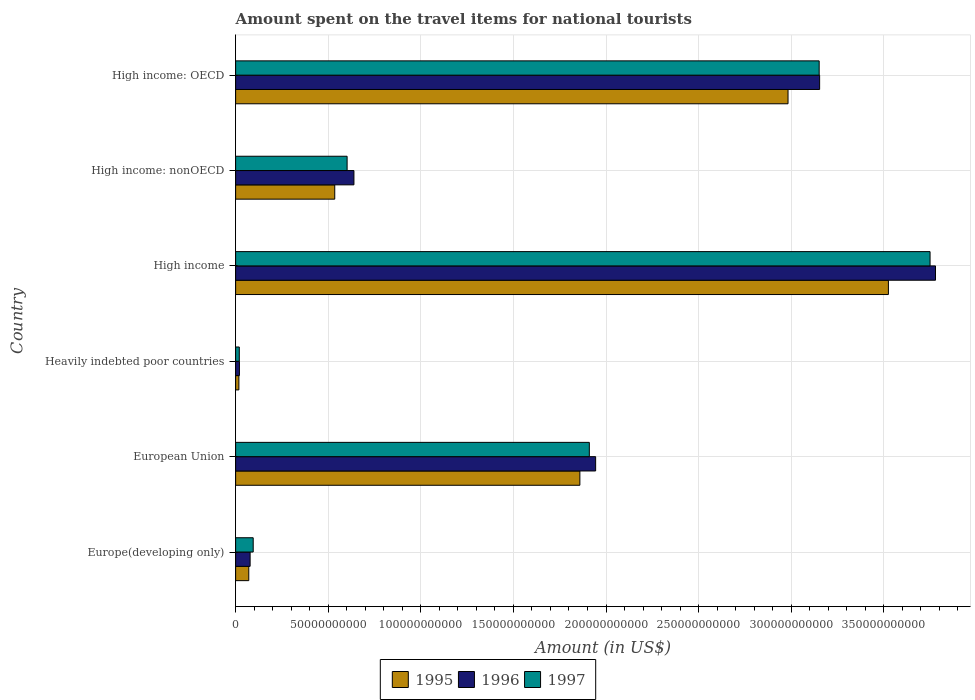How many groups of bars are there?
Offer a terse response. 6. Are the number of bars per tick equal to the number of legend labels?
Your answer should be very brief. Yes. What is the label of the 3rd group of bars from the top?
Your response must be concise. High income. What is the amount spent on the travel items for national tourists in 1995 in High income: nonOECD?
Keep it short and to the point. 5.35e+1. Across all countries, what is the maximum amount spent on the travel items for national tourists in 1997?
Offer a terse response. 3.75e+11. Across all countries, what is the minimum amount spent on the travel items for national tourists in 1995?
Give a very brief answer. 1.77e+09. In which country was the amount spent on the travel items for national tourists in 1996 maximum?
Your answer should be very brief. High income. In which country was the amount spent on the travel items for national tourists in 1995 minimum?
Your answer should be compact. Heavily indebted poor countries. What is the total amount spent on the travel items for national tourists in 1996 in the graph?
Your response must be concise. 9.61e+11. What is the difference between the amount spent on the travel items for national tourists in 1995 in High income and that in High income: OECD?
Provide a succinct answer. 5.42e+1. What is the difference between the amount spent on the travel items for national tourists in 1996 in High income: OECD and the amount spent on the travel items for national tourists in 1997 in High income: nonOECD?
Your answer should be very brief. 2.55e+11. What is the average amount spent on the travel items for national tourists in 1995 per country?
Your answer should be very brief. 1.50e+11. What is the difference between the amount spent on the travel items for national tourists in 1995 and amount spent on the travel items for national tourists in 1997 in High income: nonOECD?
Ensure brevity in your answer.  -6.67e+09. What is the ratio of the amount spent on the travel items for national tourists in 1997 in Heavily indebted poor countries to that in High income: nonOECD?
Make the answer very short. 0.03. What is the difference between the highest and the second highest amount spent on the travel items for national tourists in 1996?
Your answer should be compact. 6.26e+1. What is the difference between the highest and the lowest amount spent on the travel items for national tourists in 1996?
Ensure brevity in your answer.  3.76e+11. What does the 3rd bar from the bottom in High income: OECD represents?
Offer a terse response. 1997. Are all the bars in the graph horizontal?
Ensure brevity in your answer.  Yes. How many countries are there in the graph?
Provide a short and direct response. 6. Are the values on the major ticks of X-axis written in scientific E-notation?
Your answer should be compact. No. Does the graph contain any zero values?
Offer a terse response. No. Where does the legend appear in the graph?
Make the answer very short. Bottom center. How many legend labels are there?
Keep it short and to the point. 3. How are the legend labels stacked?
Offer a very short reply. Horizontal. What is the title of the graph?
Your response must be concise. Amount spent on the travel items for national tourists. Does "1997" appear as one of the legend labels in the graph?
Keep it short and to the point. Yes. What is the label or title of the Y-axis?
Offer a very short reply. Country. What is the Amount (in US$) in 1995 in Europe(developing only)?
Make the answer very short. 7.10e+09. What is the Amount (in US$) in 1996 in Europe(developing only)?
Provide a succinct answer. 7.83e+09. What is the Amount (in US$) of 1997 in Europe(developing only)?
Your answer should be very brief. 9.50e+09. What is the Amount (in US$) in 1995 in European Union?
Your answer should be compact. 1.86e+11. What is the Amount (in US$) of 1996 in European Union?
Make the answer very short. 1.94e+11. What is the Amount (in US$) of 1997 in European Union?
Provide a short and direct response. 1.91e+11. What is the Amount (in US$) of 1995 in Heavily indebted poor countries?
Your answer should be very brief. 1.77e+09. What is the Amount (in US$) of 1996 in Heavily indebted poor countries?
Your answer should be very brief. 2.06e+09. What is the Amount (in US$) in 1997 in Heavily indebted poor countries?
Your answer should be very brief. 1.99e+09. What is the Amount (in US$) of 1995 in High income?
Ensure brevity in your answer.  3.52e+11. What is the Amount (in US$) in 1996 in High income?
Provide a succinct answer. 3.78e+11. What is the Amount (in US$) of 1997 in High income?
Give a very brief answer. 3.75e+11. What is the Amount (in US$) in 1995 in High income: nonOECD?
Your response must be concise. 5.35e+1. What is the Amount (in US$) in 1996 in High income: nonOECD?
Your answer should be very brief. 6.39e+1. What is the Amount (in US$) of 1997 in High income: nonOECD?
Offer a very short reply. 6.02e+1. What is the Amount (in US$) in 1995 in High income: OECD?
Offer a very short reply. 2.98e+11. What is the Amount (in US$) in 1996 in High income: OECD?
Provide a succinct answer. 3.15e+11. What is the Amount (in US$) of 1997 in High income: OECD?
Offer a very short reply. 3.15e+11. Across all countries, what is the maximum Amount (in US$) in 1995?
Your answer should be very brief. 3.52e+11. Across all countries, what is the maximum Amount (in US$) of 1996?
Offer a terse response. 3.78e+11. Across all countries, what is the maximum Amount (in US$) in 1997?
Offer a very short reply. 3.75e+11. Across all countries, what is the minimum Amount (in US$) of 1995?
Offer a terse response. 1.77e+09. Across all countries, what is the minimum Amount (in US$) of 1996?
Offer a terse response. 2.06e+09. Across all countries, what is the minimum Amount (in US$) of 1997?
Offer a terse response. 1.99e+09. What is the total Amount (in US$) of 1995 in the graph?
Your response must be concise. 8.99e+11. What is the total Amount (in US$) in 1996 in the graph?
Provide a succinct answer. 9.61e+11. What is the total Amount (in US$) in 1997 in the graph?
Offer a terse response. 9.53e+11. What is the difference between the Amount (in US$) in 1995 in Europe(developing only) and that in European Union?
Provide a succinct answer. -1.79e+11. What is the difference between the Amount (in US$) of 1996 in Europe(developing only) and that in European Union?
Your response must be concise. -1.87e+11. What is the difference between the Amount (in US$) of 1997 in Europe(developing only) and that in European Union?
Ensure brevity in your answer.  -1.81e+11. What is the difference between the Amount (in US$) in 1995 in Europe(developing only) and that in Heavily indebted poor countries?
Offer a terse response. 5.34e+09. What is the difference between the Amount (in US$) in 1996 in Europe(developing only) and that in Heavily indebted poor countries?
Make the answer very short. 5.77e+09. What is the difference between the Amount (in US$) in 1997 in Europe(developing only) and that in Heavily indebted poor countries?
Keep it short and to the point. 7.51e+09. What is the difference between the Amount (in US$) in 1995 in Europe(developing only) and that in High income?
Offer a terse response. -3.45e+11. What is the difference between the Amount (in US$) of 1996 in Europe(developing only) and that in High income?
Provide a succinct answer. -3.70e+11. What is the difference between the Amount (in US$) in 1997 in Europe(developing only) and that in High income?
Provide a short and direct response. -3.65e+11. What is the difference between the Amount (in US$) in 1995 in Europe(developing only) and that in High income: nonOECD?
Provide a succinct answer. -4.64e+1. What is the difference between the Amount (in US$) of 1996 in Europe(developing only) and that in High income: nonOECD?
Your answer should be compact. -5.61e+1. What is the difference between the Amount (in US$) in 1997 in Europe(developing only) and that in High income: nonOECD?
Offer a very short reply. -5.07e+1. What is the difference between the Amount (in US$) in 1995 in Europe(developing only) and that in High income: OECD?
Your answer should be very brief. -2.91e+11. What is the difference between the Amount (in US$) in 1996 in Europe(developing only) and that in High income: OECD?
Your response must be concise. -3.08e+11. What is the difference between the Amount (in US$) of 1997 in Europe(developing only) and that in High income: OECD?
Provide a short and direct response. -3.06e+11. What is the difference between the Amount (in US$) in 1995 in European Union and that in Heavily indebted poor countries?
Your response must be concise. 1.84e+11. What is the difference between the Amount (in US$) of 1996 in European Union and that in Heavily indebted poor countries?
Make the answer very short. 1.92e+11. What is the difference between the Amount (in US$) of 1997 in European Union and that in Heavily indebted poor countries?
Keep it short and to the point. 1.89e+11. What is the difference between the Amount (in US$) of 1995 in European Union and that in High income?
Give a very brief answer. -1.67e+11. What is the difference between the Amount (in US$) in 1996 in European Union and that in High income?
Give a very brief answer. -1.84e+11. What is the difference between the Amount (in US$) of 1997 in European Union and that in High income?
Offer a very short reply. -1.84e+11. What is the difference between the Amount (in US$) of 1995 in European Union and that in High income: nonOECD?
Offer a terse response. 1.32e+11. What is the difference between the Amount (in US$) in 1996 in European Union and that in High income: nonOECD?
Provide a short and direct response. 1.31e+11. What is the difference between the Amount (in US$) in 1997 in European Union and that in High income: nonOECD?
Your response must be concise. 1.31e+11. What is the difference between the Amount (in US$) in 1995 in European Union and that in High income: OECD?
Make the answer very short. -1.12e+11. What is the difference between the Amount (in US$) of 1996 in European Union and that in High income: OECD?
Your answer should be compact. -1.21e+11. What is the difference between the Amount (in US$) in 1997 in European Union and that in High income: OECD?
Provide a succinct answer. -1.24e+11. What is the difference between the Amount (in US$) of 1995 in Heavily indebted poor countries and that in High income?
Give a very brief answer. -3.51e+11. What is the difference between the Amount (in US$) in 1996 in Heavily indebted poor countries and that in High income?
Provide a short and direct response. -3.76e+11. What is the difference between the Amount (in US$) of 1997 in Heavily indebted poor countries and that in High income?
Your response must be concise. -3.73e+11. What is the difference between the Amount (in US$) of 1995 in Heavily indebted poor countries and that in High income: nonOECD?
Your answer should be compact. -5.18e+1. What is the difference between the Amount (in US$) in 1996 in Heavily indebted poor countries and that in High income: nonOECD?
Offer a terse response. -6.18e+1. What is the difference between the Amount (in US$) of 1997 in Heavily indebted poor countries and that in High income: nonOECD?
Make the answer very short. -5.82e+1. What is the difference between the Amount (in US$) of 1995 in Heavily indebted poor countries and that in High income: OECD?
Keep it short and to the point. -2.97e+11. What is the difference between the Amount (in US$) in 1996 in Heavily indebted poor countries and that in High income: OECD?
Offer a terse response. -3.13e+11. What is the difference between the Amount (in US$) of 1997 in Heavily indebted poor countries and that in High income: OECD?
Make the answer very short. -3.13e+11. What is the difference between the Amount (in US$) of 1995 in High income and that in High income: nonOECD?
Give a very brief answer. 2.99e+11. What is the difference between the Amount (in US$) in 1996 in High income and that in High income: nonOECD?
Make the answer very short. 3.14e+11. What is the difference between the Amount (in US$) of 1997 in High income and that in High income: nonOECD?
Provide a succinct answer. 3.15e+11. What is the difference between the Amount (in US$) of 1995 in High income and that in High income: OECD?
Give a very brief answer. 5.42e+1. What is the difference between the Amount (in US$) in 1996 in High income and that in High income: OECD?
Your response must be concise. 6.26e+1. What is the difference between the Amount (in US$) in 1997 in High income and that in High income: OECD?
Your answer should be very brief. 5.99e+1. What is the difference between the Amount (in US$) in 1995 in High income: nonOECD and that in High income: OECD?
Make the answer very short. -2.45e+11. What is the difference between the Amount (in US$) in 1996 in High income: nonOECD and that in High income: OECD?
Make the answer very short. -2.51e+11. What is the difference between the Amount (in US$) in 1997 in High income: nonOECD and that in High income: OECD?
Ensure brevity in your answer.  -2.55e+11. What is the difference between the Amount (in US$) of 1995 in Europe(developing only) and the Amount (in US$) of 1996 in European Union?
Make the answer very short. -1.87e+11. What is the difference between the Amount (in US$) in 1995 in Europe(developing only) and the Amount (in US$) in 1997 in European Union?
Your response must be concise. -1.84e+11. What is the difference between the Amount (in US$) in 1996 in Europe(developing only) and the Amount (in US$) in 1997 in European Union?
Ensure brevity in your answer.  -1.83e+11. What is the difference between the Amount (in US$) in 1995 in Europe(developing only) and the Amount (in US$) in 1996 in Heavily indebted poor countries?
Your answer should be compact. 5.05e+09. What is the difference between the Amount (in US$) of 1995 in Europe(developing only) and the Amount (in US$) of 1997 in Heavily indebted poor countries?
Make the answer very short. 5.12e+09. What is the difference between the Amount (in US$) of 1996 in Europe(developing only) and the Amount (in US$) of 1997 in Heavily indebted poor countries?
Your response must be concise. 5.84e+09. What is the difference between the Amount (in US$) in 1995 in Europe(developing only) and the Amount (in US$) in 1996 in High income?
Your response must be concise. -3.71e+11. What is the difference between the Amount (in US$) of 1995 in Europe(developing only) and the Amount (in US$) of 1997 in High income?
Your response must be concise. -3.68e+11. What is the difference between the Amount (in US$) in 1996 in Europe(developing only) and the Amount (in US$) in 1997 in High income?
Make the answer very short. -3.67e+11. What is the difference between the Amount (in US$) in 1995 in Europe(developing only) and the Amount (in US$) in 1996 in High income: nonOECD?
Provide a succinct answer. -5.68e+1. What is the difference between the Amount (in US$) in 1995 in Europe(developing only) and the Amount (in US$) in 1997 in High income: nonOECD?
Give a very brief answer. -5.31e+1. What is the difference between the Amount (in US$) of 1996 in Europe(developing only) and the Amount (in US$) of 1997 in High income: nonOECD?
Provide a succinct answer. -5.24e+1. What is the difference between the Amount (in US$) of 1995 in Europe(developing only) and the Amount (in US$) of 1996 in High income: OECD?
Make the answer very short. -3.08e+11. What is the difference between the Amount (in US$) of 1995 in Europe(developing only) and the Amount (in US$) of 1997 in High income: OECD?
Provide a short and direct response. -3.08e+11. What is the difference between the Amount (in US$) of 1996 in Europe(developing only) and the Amount (in US$) of 1997 in High income: OECD?
Your response must be concise. -3.07e+11. What is the difference between the Amount (in US$) in 1995 in European Union and the Amount (in US$) in 1996 in Heavily indebted poor countries?
Give a very brief answer. 1.84e+11. What is the difference between the Amount (in US$) in 1995 in European Union and the Amount (in US$) in 1997 in Heavily indebted poor countries?
Make the answer very short. 1.84e+11. What is the difference between the Amount (in US$) of 1996 in European Union and the Amount (in US$) of 1997 in Heavily indebted poor countries?
Offer a terse response. 1.92e+11. What is the difference between the Amount (in US$) in 1995 in European Union and the Amount (in US$) in 1996 in High income?
Give a very brief answer. -1.92e+11. What is the difference between the Amount (in US$) of 1995 in European Union and the Amount (in US$) of 1997 in High income?
Offer a very short reply. -1.89e+11. What is the difference between the Amount (in US$) of 1996 in European Union and the Amount (in US$) of 1997 in High income?
Your response must be concise. -1.81e+11. What is the difference between the Amount (in US$) of 1995 in European Union and the Amount (in US$) of 1996 in High income: nonOECD?
Provide a short and direct response. 1.22e+11. What is the difference between the Amount (in US$) of 1995 in European Union and the Amount (in US$) of 1997 in High income: nonOECD?
Offer a terse response. 1.26e+11. What is the difference between the Amount (in US$) in 1996 in European Union and the Amount (in US$) in 1997 in High income: nonOECD?
Give a very brief answer. 1.34e+11. What is the difference between the Amount (in US$) of 1995 in European Union and the Amount (in US$) of 1996 in High income: OECD?
Keep it short and to the point. -1.29e+11. What is the difference between the Amount (in US$) in 1995 in European Union and the Amount (in US$) in 1997 in High income: OECD?
Your answer should be compact. -1.29e+11. What is the difference between the Amount (in US$) in 1996 in European Union and the Amount (in US$) in 1997 in High income: OECD?
Your answer should be very brief. -1.21e+11. What is the difference between the Amount (in US$) of 1995 in Heavily indebted poor countries and the Amount (in US$) of 1996 in High income?
Your answer should be compact. -3.76e+11. What is the difference between the Amount (in US$) in 1995 in Heavily indebted poor countries and the Amount (in US$) in 1997 in High income?
Make the answer very short. -3.73e+11. What is the difference between the Amount (in US$) in 1996 in Heavily indebted poor countries and the Amount (in US$) in 1997 in High income?
Make the answer very short. -3.73e+11. What is the difference between the Amount (in US$) of 1995 in Heavily indebted poor countries and the Amount (in US$) of 1996 in High income: nonOECD?
Make the answer very short. -6.21e+1. What is the difference between the Amount (in US$) of 1995 in Heavily indebted poor countries and the Amount (in US$) of 1997 in High income: nonOECD?
Make the answer very short. -5.84e+1. What is the difference between the Amount (in US$) of 1996 in Heavily indebted poor countries and the Amount (in US$) of 1997 in High income: nonOECD?
Provide a succinct answer. -5.81e+1. What is the difference between the Amount (in US$) of 1995 in Heavily indebted poor countries and the Amount (in US$) of 1996 in High income: OECD?
Your answer should be compact. -3.14e+11. What is the difference between the Amount (in US$) of 1995 in Heavily indebted poor countries and the Amount (in US$) of 1997 in High income: OECD?
Your answer should be very brief. -3.13e+11. What is the difference between the Amount (in US$) in 1996 in Heavily indebted poor countries and the Amount (in US$) in 1997 in High income: OECD?
Ensure brevity in your answer.  -3.13e+11. What is the difference between the Amount (in US$) in 1995 in High income and the Amount (in US$) in 1996 in High income: nonOECD?
Offer a terse response. 2.89e+11. What is the difference between the Amount (in US$) in 1995 in High income and the Amount (in US$) in 1997 in High income: nonOECD?
Your answer should be compact. 2.92e+11. What is the difference between the Amount (in US$) in 1996 in High income and the Amount (in US$) in 1997 in High income: nonOECD?
Keep it short and to the point. 3.18e+11. What is the difference between the Amount (in US$) of 1995 in High income and the Amount (in US$) of 1996 in High income: OECD?
Make the answer very short. 3.71e+1. What is the difference between the Amount (in US$) in 1995 in High income and the Amount (in US$) in 1997 in High income: OECD?
Make the answer very short. 3.74e+1. What is the difference between the Amount (in US$) of 1996 in High income and the Amount (in US$) of 1997 in High income: OECD?
Give a very brief answer. 6.28e+1. What is the difference between the Amount (in US$) of 1995 in High income: nonOECD and the Amount (in US$) of 1996 in High income: OECD?
Offer a very short reply. -2.62e+11. What is the difference between the Amount (in US$) in 1995 in High income: nonOECD and the Amount (in US$) in 1997 in High income: OECD?
Make the answer very short. -2.62e+11. What is the difference between the Amount (in US$) in 1996 in High income: nonOECD and the Amount (in US$) in 1997 in High income: OECD?
Your answer should be very brief. -2.51e+11. What is the average Amount (in US$) of 1995 per country?
Keep it short and to the point. 1.50e+11. What is the average Amount (in US$) of 1996 per country?
Offer a very short reply. 1.60e+11. What is the average Amount (in US$) in 1997 per country?
Provide a succinct answer. 1.59e+11. What is the difference between the Amount (in US$) in 1995 and Amount (in US$) in 1996 in Europe(developing only)?
Make the answer very short. -7.25e+08. What is the difference between the Amount (in US$) of 1995 and Amount (in US$) of 1997 in Europe(developing only)?
Your answer should be compact. -2.39e+09. What is the difference between the Amount (in US$) in 1996 and Amount (in US$) in 1997 in Europe(developing only)?
Your response must be concise. -1.67e+09. What is the difference between the Amount (in US$) of 1995 and Amount (in US$) of 1996 in European Union?
Ensure brevity in your answer.  -8.51e+09. What is the difference between the Amount (in US$) in 1995 and Amount (in US$) in 1997 in European Union?
Provide a succinct answer. -5.10e+09. What is the difference between the Amount (in US$) in 1996 and Amount (in US$) in 1997 in European Union?
Ensure brevity in your answer.  3.41e+09. What is the difference between the Amount (in US$) in 1995 and Amount (in US$) in 1996 in Heavily indebted poor countries?
Your answer should be very brief. -2.89e+08. What is the difference between the Amount (in US$) of 1995 and Amount (in US$) of 1997 in Heavily indebted poor countries?
Make the answer very short. -2.21e+08. What is the difference between the Amount (in US$) of 1996 and Amount (in US$) of 1997 in Heavily indebted poor countries?
Keep it short and to the point. 6.82e+07. What is the difference between the Amount (in US$) of 1995 and Amount (in US$) of 1996 in High income?
Offer a terse response. -2.54e+1. What is the difference between the Amount (in US$) of 1995 and Amount (in US$) of 1997 in High income?
Make the answer very short. -2.25e+1. What is the difference between the Amount (in US$) of 1996 and Amount (in US$) of 1997 in High income?
Your answer should be very brief. 2.94e+09. What is the difference between the Amount (in US$) in 1995 and Amount (in US$) in 1996 in High income: nonOECD?
Your answer should be very brief. -1.04e+1. What is the difference between the Amount (in US$) of 1995 and Amount (in US$) of 1997 in High income: nonOECD?
Offer a very short reply. -6.67e+09. What is the difference between the Amount (in US$) in 1996 and Amount (in US$) in 1997 in High income: nonOECD?
Make the answer very short. 3.69e+09. What is the difference between the Amount (in US$) in 1995 and Amount (in US$) in 1996 in High income: OECD?
Provide a succinct answer. -1.71e+1. What is the difference between the Amount (in US$) in 1995 and Amount (in US$) in 1997 in High income: OECD?
Provide a short and direct response. -1.68e+1. What is the difference between the Amount (in US$) of 1996 and Amount (in US$) of 1997 in High income: OECD?
Offer a terse response. 2.50e+08. What is the ratio of the Amount (in US$) in 1995 in Europe(developing only) to that in European Union?
Your answer should be very brief. 0.04. What is the ratio of the Amount (in US$) in 1996 in Europe(developing only) to that in European Union?
Keep it short and to the point. 0.04. What is the ratio of the Amount (in US$) of 1997 in Europe(developing only) to that in European Union?
Provide a succinct answer. 0.05. What is the ratio of the Amount (in US$) of 1995 in Europe(developing only) to that in Heavily indebted poor countries?
Offer a very short reply. 4.02. What is the ratio of the Amount (in US$) in 1996 in Europe(developing only) to that in Heavily indebted poor countries?
Offer a very short reply. 3.81. What is the ratio of the Amount (in US$) in 1997 in Europe(developing only) to that in Heavily indebted poor countries?
Ensure brevity in your answer.  4.78. What is the ratio of the Amount (in US$) of 1995 in Europe(developing only) to that in High income?
Keep it short and to the point. 0.02. What is the ratio of the Amount (in US$) of 1996 in Europe(developing only) to that in High income?
Provide a short and direct response. 0.02. What is the ratio of the Amount (in US$) in 1997 in Europe(developing only) to that in High income?
Your answer should be compact. 0.03. What is the ratio of the Amount (in US$) in 1995 in Europe(developing only) to that in High income: nonOECD?
Your response must be concise. 0.13. What is the ratio of the Amount (in US$) in 1996 in Europe(developing only) to that in High income: nonOECD?
Provide a succinct answer. 0.12. What is the ratio of the Amount (in US$) of 1997 in Europe(developing only) to that in High income: nonOECD?
Give a very brief answer. 0.16. What is the ratio of the Amount (in US$) of 1995 in Europe(developing only) to that in High income: OECD?
Ensure brevity in your answer.  0.02. What is the ratio of the Amount (in US$) in 1996 in Europe(developing only) to that in High income: OECD?
Your answer should be very brief. 0.02. What is the ratio of the Amount (in US$) of 1997 in Europe(developing only) to that in High income: OECD?
Offer a terse response. 0.03. What is the ratio of the Amount (in US$) of 1995 in European Union to that in Heavily indebted poor countries?
Make the answer very short. 105.17. What is the ratio of the Amount (in US$) of 1996 in European Union to that in Heavily indebted poor countries?
Your answer should be very brief. 94.53. What is the ratio of the Amount (in US$) of 1997 in European Union to that in Heavily indebted poor countries?
Make the answer very short. 96.05. What is the ratio of the Amount (in US$) of 1995 in European Union to that in High income?
Provide a succinct answer. 0.53. What is the ratio of the Amount (in US$) in 1996 in European Union to that in High income?
Make the answer very short. 0.51. What is the ratio of the Amount (in US$) in 1997 in European Union to that in High income?
Offer a terse response. 0.51. What is the ratio of the Amount (in US$) of 1995 in European Union to that in High income: nonOECD?
Ensure brevity in your answer.  3.47. What is the ratio of the Amount (in US$) in 1996 in European Union to that in High income: nonOECD?
Ensure brevity in your answer.  3.04. What is the ratio of the Amount (in US$) of 1997 in European Union to that in High income: nonOECD?
Offer a very short reply. 3.17. What is the ratio of the Amount (in US$) of 1995 in European Union to that in High income: OECD?
Your response must be concise. 0.62. What is the ratio of the Amount (in US$) of 1996 in European Union to that in High income: OECD?
Keep it short and to the point. 0.62. What is the ratio of the Amount (in US$) in 1997 in European Union to that in High income: OECD?
Your answer should be very brief. 0.61. What is the ratio of the Amount (in US$) in 1995 in Heavily indebted poor countries to that in High income?
Ensure brevity in your answer.  0.01. What is the ratio of the Amount (in US$) of 1996 in Heavily indebted poor countries to that in High income?
Provide a succinct answer. 0.01. What is the ratio of the Amount (in US$) of 1997 in Heavily indebted poor countries to that in High income?
Offer a terse response. 0.01. What is the ratio of the Amount (in US$) in 1995 in Heavily indebted poor countries to that in High income: nonOECD?
Provide a short and direct response. 0.03. What is the ratio of the Amount (in US$) in 1996 in Heavily indebted poor countries to that in High income: nonOECD?
Offer a terse response. 0.03. What is the ratio of the Amount (in US$) in 1997 in Heavily indebted poor countries to that in High income: nonOECD?
Ensure brevity in your answer.  0.03. What is the ratio of the Amount (in US$) of 1995 in Heavily indebted poor countries to that in High income: OECD?
Your response must be concise. 0.01. What is the ratio of the Amount (in US$) in 1996 in Heavily indebted poor countries to that in High income: OECD?
Your answer should be compact. 0.01. What is the ratio of the Amount (in US$) of 1997 in Heavily indebted poor countries to that in High income: OECD?
Offer a very short reply. 0.01. What is the ratio of the Amount (in US$) in 1995 in High income to that in High income: nonOECD?
Your answer should be compact. 6.58. What is the ratio of the Amount (in US$) of 1996 in High income to that in High income: nonOECD?
Ensure brevity in your answer.  5.91. What is the ratio of the Amount (in US$) of 1997 in High income to that in High income: nonOECD?
Offer a very short reply. 6.23. What is the ratio of the Amount (in US$) in 1995 in High income to that in High income: OECD?
Keep it short and to the point. 1.18. What is the ratio of the Amount (in US$) in 1996 in High income to that in High income: OECD?
Ensure brevity in your answer.  1.2. What is the ratio of the Amount (in US$) in 1997 in High income to that in High income: OECD?
Keep it short and to the point. 1.19. What is the ratio of the Amount (in US$) in 1995 in High income: nonOECD to that in High income: OECD?
Your answer should be compact. 0.18. What is the ratio of the Amount (in US$) in 1996 in High income: nonOECD to that in High income: OECD?
Your answer should be very brief. 0.2. What is the ratio of the Amount (in US$) in 1997 in High income: nonOECD to that in High income: OECD?
Give a very brief answer. 0.19. What is the difference between the highest and the second highest Amount (in US$) of 1995?
Make the answer very short. 5.42e+1. What is the difference between the highest and the second highest Amount (in US$) in 1996?
Offer a terse response. 6.26e+1. What is the difference between the highest and the second highest Amount (in US$) in 1997?
Keep it short and to the point. 5.99e+1. What is the difference between the highest and the lowest Amount (in US$) of 1995?
Ensure brevity in your answer.  3.51e+11. What is the difference between the highest and the lowest Amount (in US$) of 1996?
Your response must be concise. 3.76e+11. What is the difference between the highest and the lowest Amount (in US$) of 1997?
Your answer should be compact. 3.73e+11. 